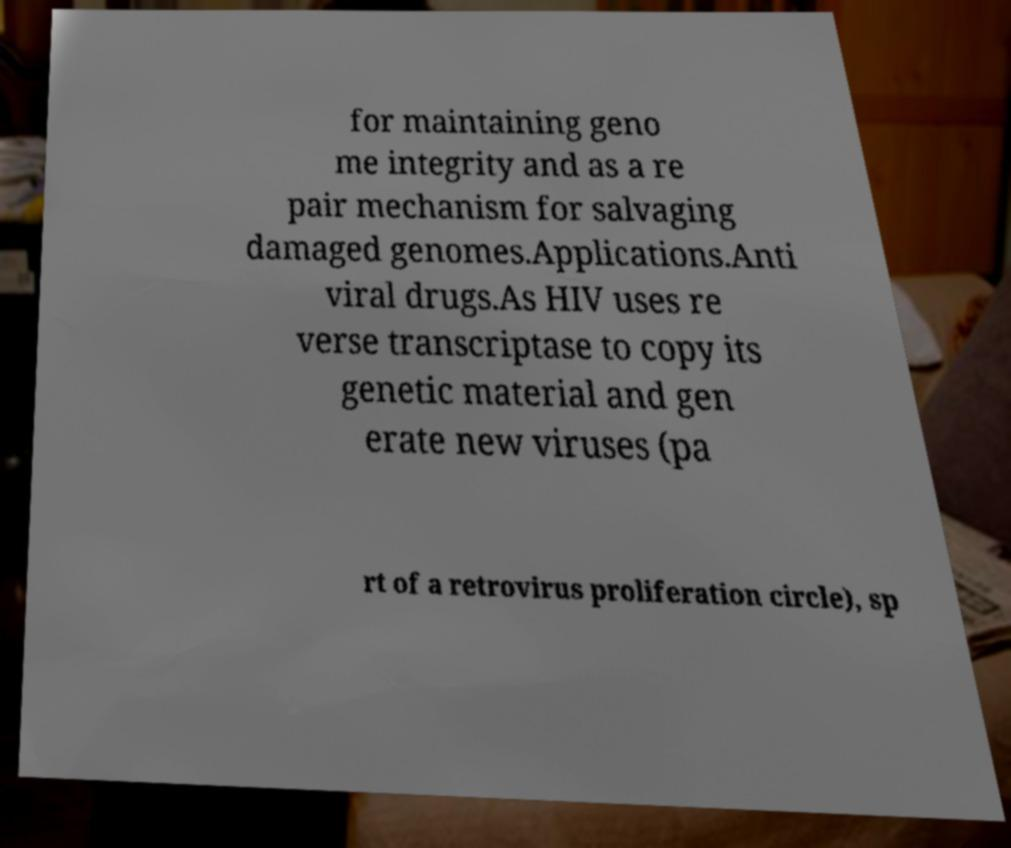For documentation purposes, I need the text within this image transcribed. Could you provide that? for maintaining geno me integrity and as a re pair mechanism for salvaging damaged genomes.Applications.Anti viral drugs.As HIV uses re verse transcriptase to copy its genetic material and gen erate new viruses (pa rt of a retrovirus proliferation circle), sp 